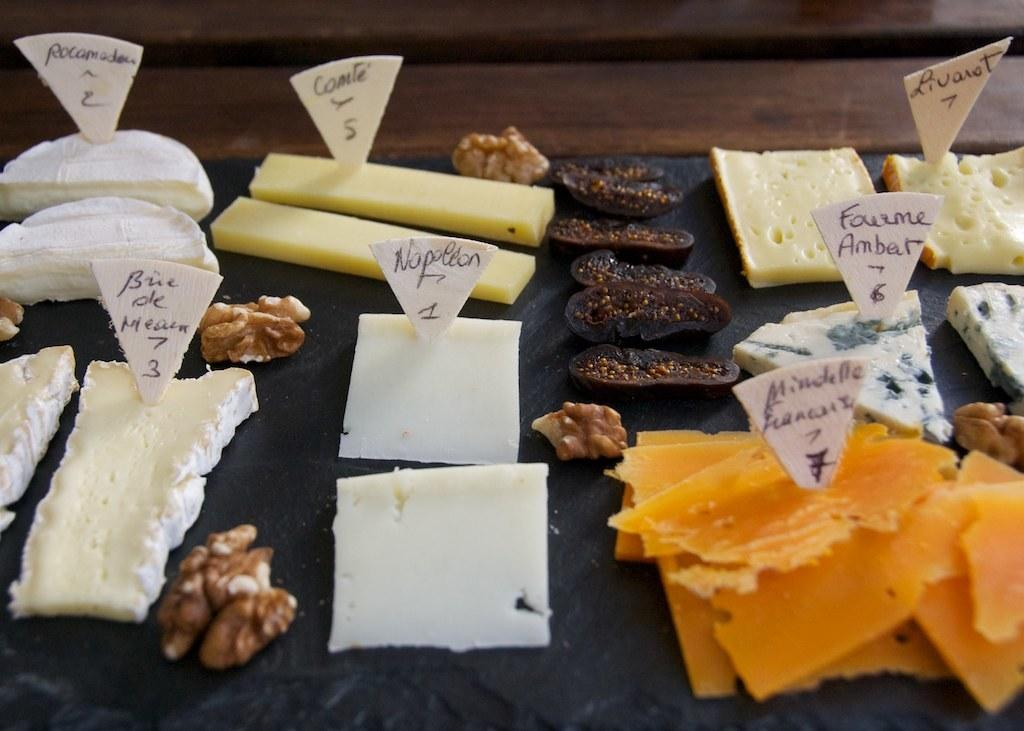What type of food is visible in the image? The image contains food, but the specific type cannot be determined from the provided facts. What else can be seen in the image besides food? There are boards with text and a wooden object at the top of the image. Can you describe the wooden object in the image? The wooden object is located at the top of the image, but its specific characteristics cannot be determined from the provided facts. What is the value of the pen in the image? There is no pen present in the image, so it is not possible to determine its value. 